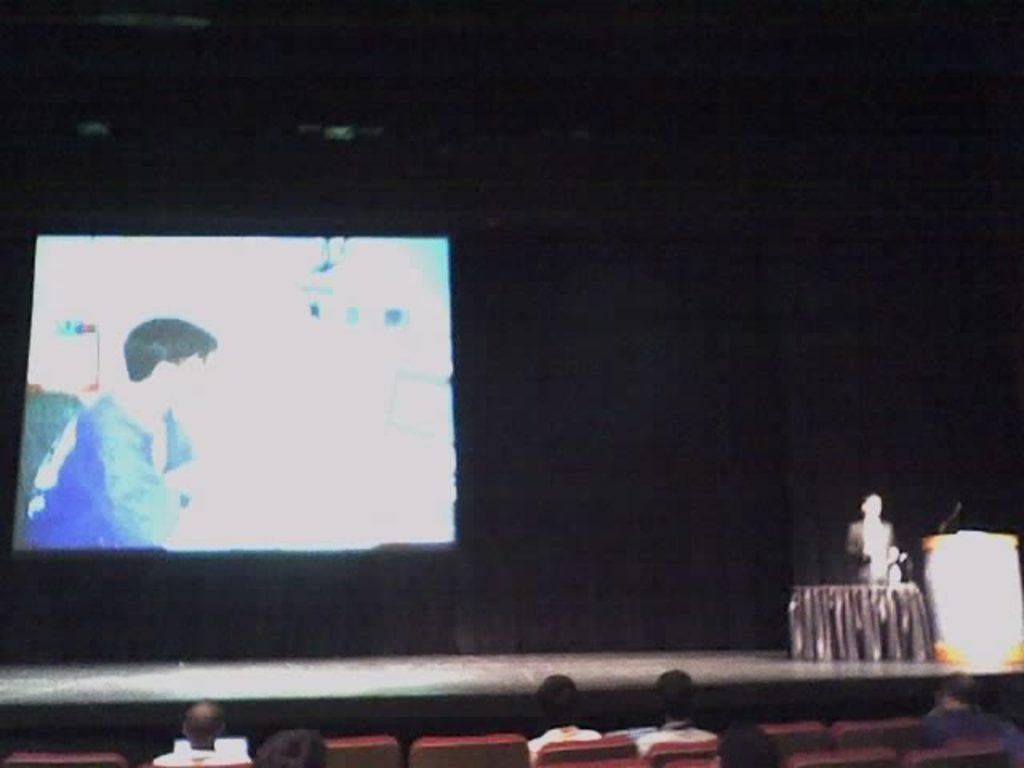What are the people in the image doing? The people in the image are sitting. What furniture can be seen at the bottom side of the image? There are chairs at the bottom side of the image. Can you describe the person standing in the image? There is a person standing in the image. What is on the desk in the image? There is a mic on a desk in the image. What is visible in the background of the image? There is a screen and curtains in the background of the image. What type of pig can be seen in the image? There is no pig present in the image. What color is the sky in the image? The sky is not visible in the image, so we cannot determine its color. 